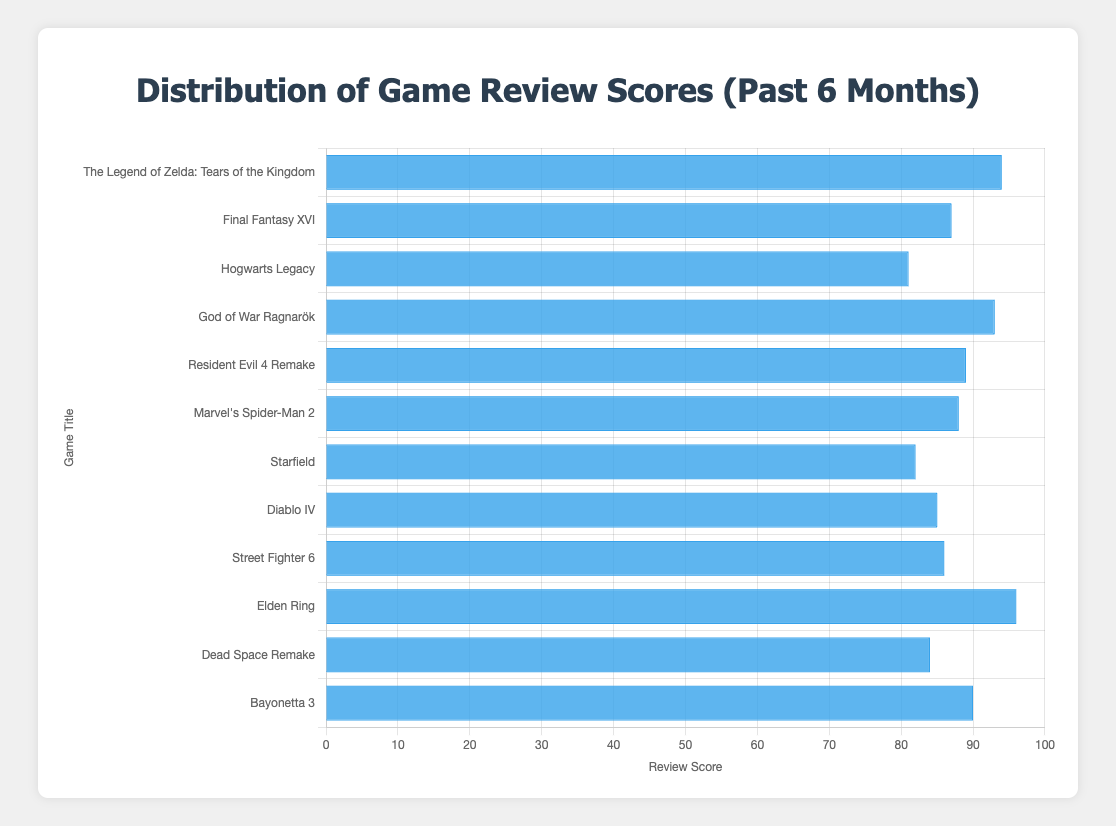Which game received the highest review score? Looking at the bar with the greatest length, we see that "Elden Ring" has the highest score of 96.
Answer: Elden Ring What is the review score of "God of War Ragnarök"? By locating the bar labeled "God of War Ragnarök", we see that it has a score of 93.
Answer: 93 Which game has a higher score, "Diablo IV" or "Dead Space Remake"? Comparing the bars for "Diablo IV" and "Dead Space Remake", "Diablo IV" has a higher score of 85 compared to 84 for "Dead Space Remake".
Answer: Diablo IV What is the difference in review scores between the highest and the lowest-scoring games? The highest score is 96 ("Elden Ring") and the lowest is 81 ("Hogwarts Legacy"), so the difference is 96 - 81.
Answer: 15 Which game scored equal to or greater than "Marvel's Spider-Man 2"? "Marvel's Spider-Man 2" scored 88. The bars with scores equal to or greater are "Elden Ring" (96), "The Legend of Zelda: Tears of the Kingdom" (94), "God of War Ragnarök" (93), "Bayonetta 3" (90), and "Resident Evil 4 Remake" (89).
Answer: Elden Ring, The Legend of Zelda: Tears of the Kingdom, God of War Ragnarök, Bayonetta 3, Resident Evil 4 Remake What is the average review score of "Street Fighter 6", "Final Fantasy XVI", and "Starfield"? Sum the scores: 86 (Street Fighter 6) + 87 (Final Fantasy XVI) + 82 (Starfield) = 255. Divide by 3 to get the average: 255 / 3.
Answer: 85 Which game received a score closest to 90? Reviewing the chart, "Bayonetta 3" received a score of 90, which is exactly 90 and closest by definition.
Answer: Bayonetta 3 Do more games score above or below 85? Count the bars above and below 85. Above: 7 games ("The Legend of Zelda: Tears of the Kingdom", "God of War Ragnarök", "Elden Ring", "Resident Evil 4 Remake", "Marvel's Spider-Man 2", "Final Fantasy XVI", "Street Fighter 6"). Below: 3 games ("Hogwarts Legacy", "Dead Space Remake", "Starfield").
Answer: Above What is the combined score of "The Legend of Zelda: Tears of the Kingdom" and "Elden Ring"? "The Legend of Zelda: Tears of the Kingdom" scored 94 and "Elden Ring" scored 96. Sum them: 94 + 96.
Answer: 190 